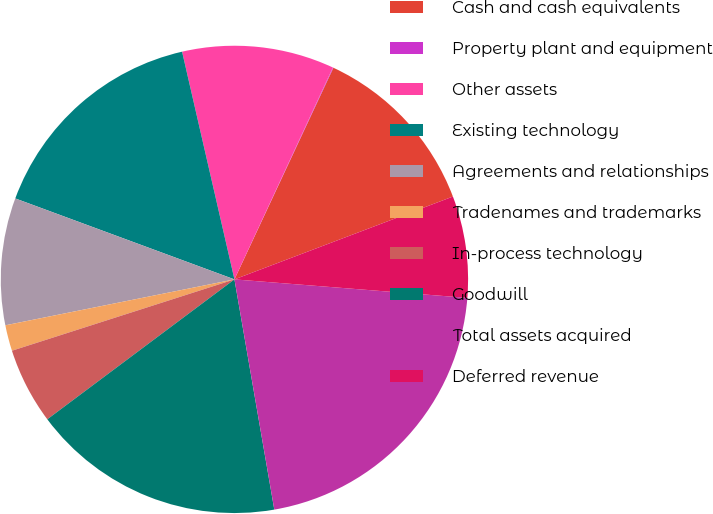Convert chart to OTSL. <chart><loc_0><loc_0><loc_500><loc_500><pie_chart><fcel>Cash and cash equivalents<fcel>Property plant and equipment<fcel>Other assets<fcel>Existing technology<fcel>Agreements and relationships<fcel>Tradenames and trademarks<fcel>In-process technology<fcel>Goodwill<fcel>Total assets acquired<fcel>Deferred revenue<nl><fcel>12.27%<fcel>0.04%<fcel>10.52%<fcel>15.77%<fcel>8.78%<fcel>1.79%<fcel>5.28%<fcel>17.51%<fcel>21.01%<fcel>7.03%<nl></chart> 